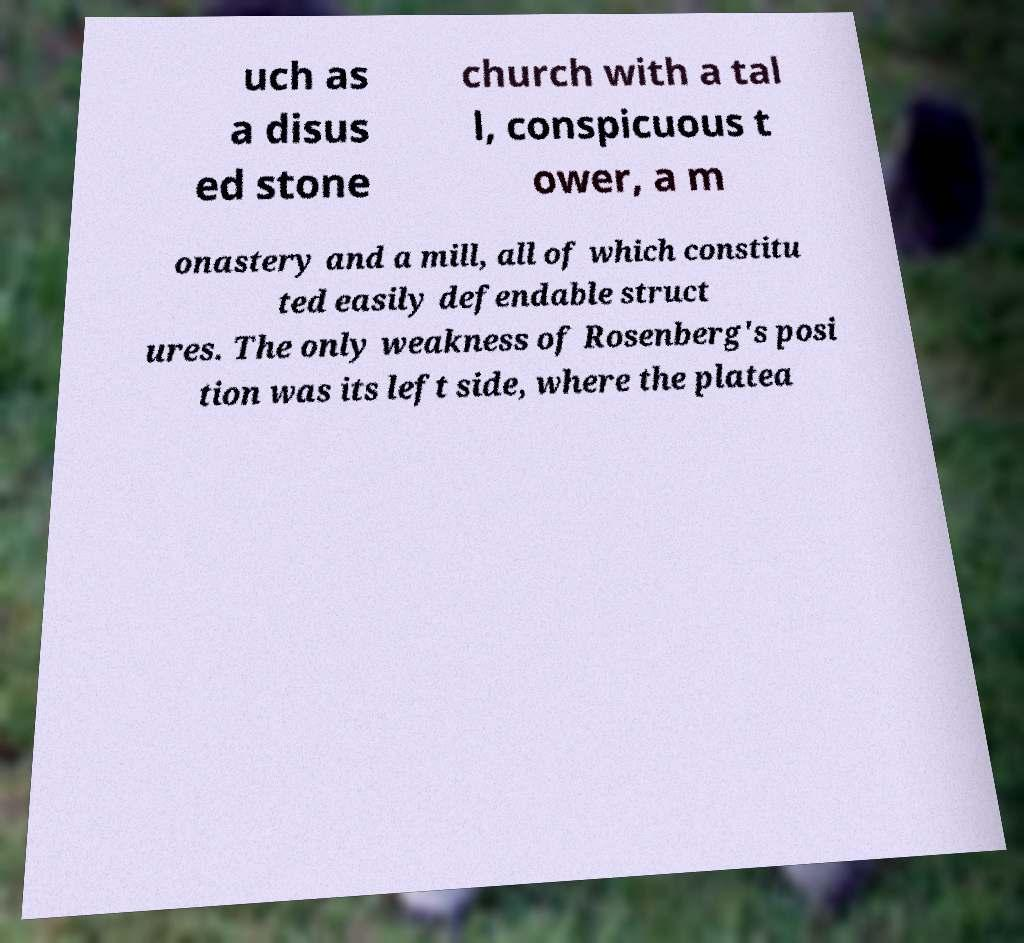I need the written content from this picture converted into text. Can you do that? uch as a disus ed stone church with a tal l, conspicuous t ower, a m onastery and a mill, all of which constitu ted easily defendable struct ures. The only weakness of Rosenberg's posi tion was its left side, where the platea 